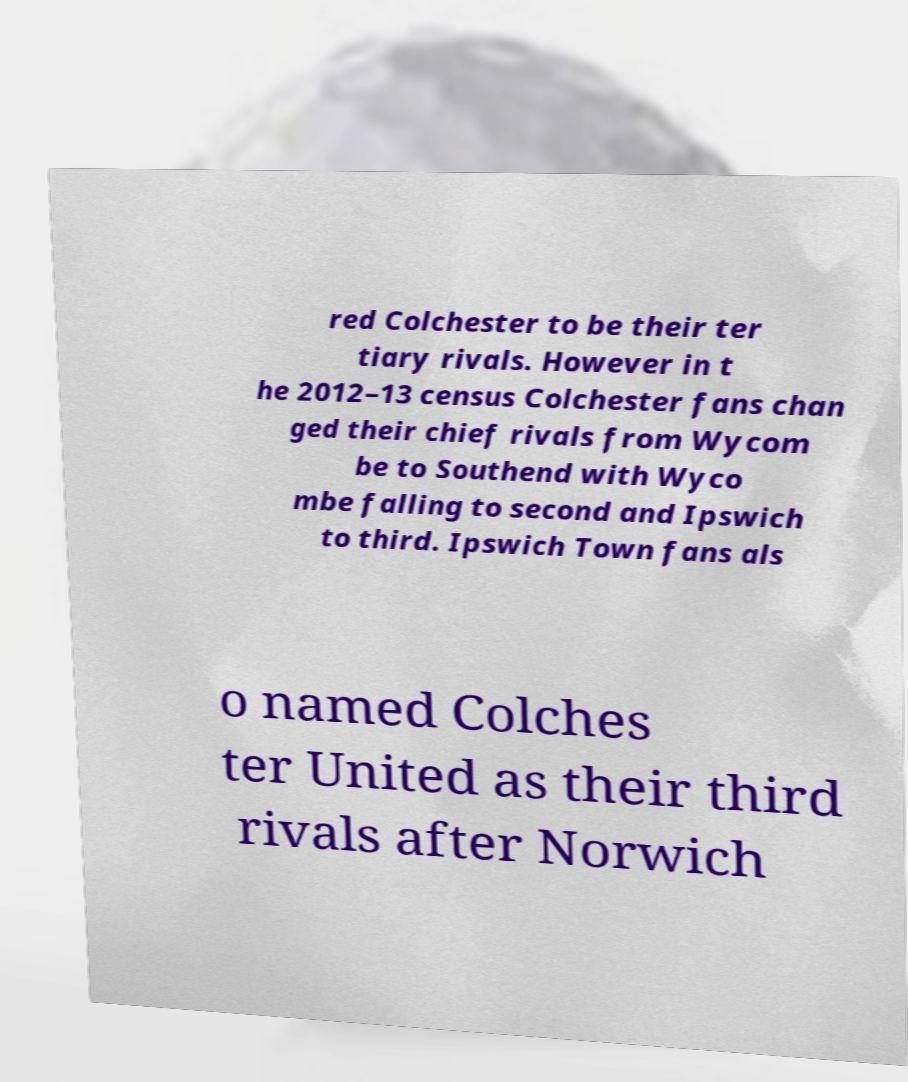Could you extract and type out the text from this image? red Colchester to be their ter tiary rivals. However in t he 2012–13 census Colchester fans chan ged their chief rivals from Wycom be to Southend with Wyco mbe falling to second and Ipswich to third. Ipswich Town fans als o named Colches ter United as their third rivals after Norwich 